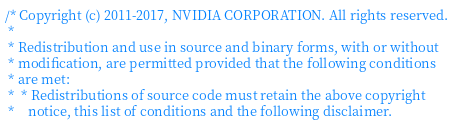<code> <loc_0><loc_0><loc_500><loc_500><_Cuda_>/* Copyright (c) 2011-2017, NVIDIA CORPORATION. All rights reserved.
 *
 * Redistribution and use in source and binary forms, with or without
 * modification, are permitted provided that the following conditions
 * are met:
 *  * Redistributions of source code must retain the above copyright
 *    notice, this list of conditions and the following disclaimer.</code> 